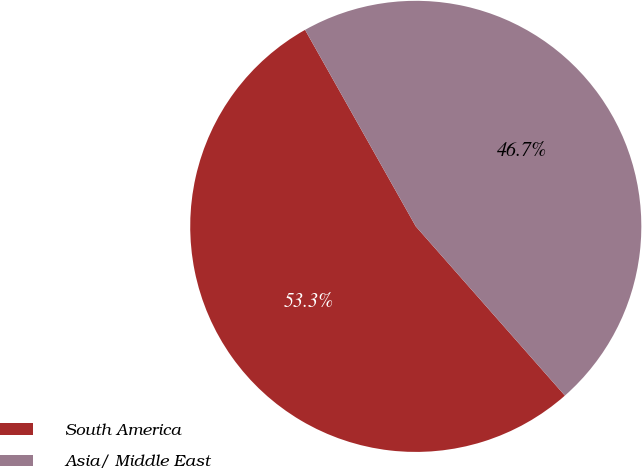Convert chart to OTSL. <chart><loc_0><loc_0><loc_500><loc_500><pie_chart><fcel>South America<fcel>Asia/ Middle East<nl><fcel>53.33%<fcel>46.67%<nl></chart> 